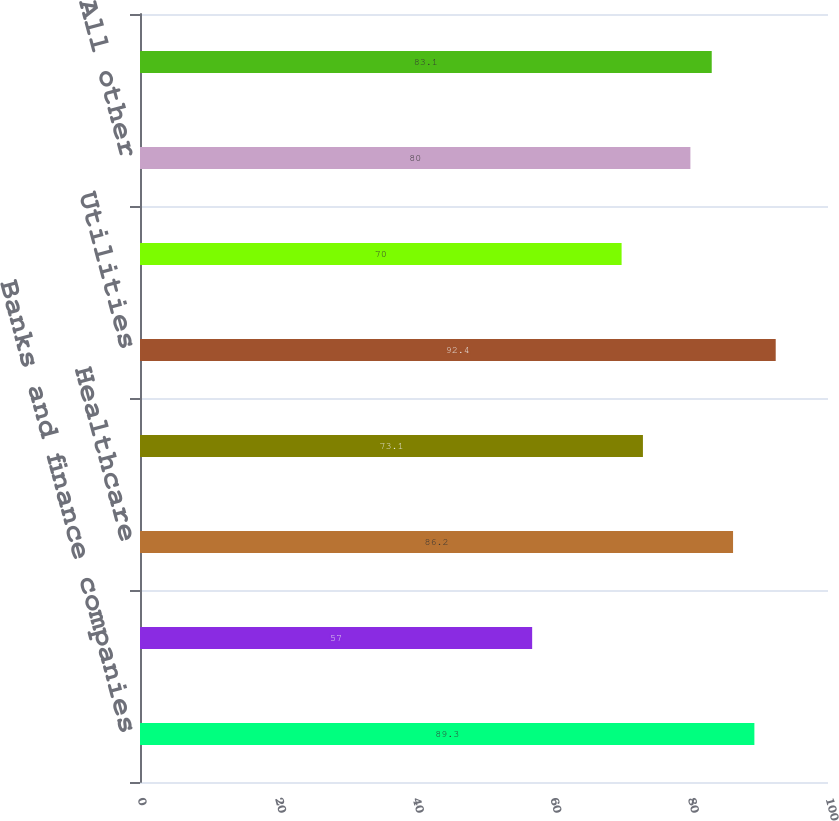<chart> <loc_0><loc_0><loc_500><loc_500><bar_chart><fcel>Banks and finance companies<fcel>Real estate<fcel>Healthcare<fcel>Consumer products<fcel>Utilities<fcel>Retail and consumer services<fcel>All other<fcel>Total excluding HFS<nl><fcel>89.3<fcel>57<fcel>86.2<fcel>73.1<fcel>92.4<fcel>70<fcel>80<fcel>83.1<nl></chart> 